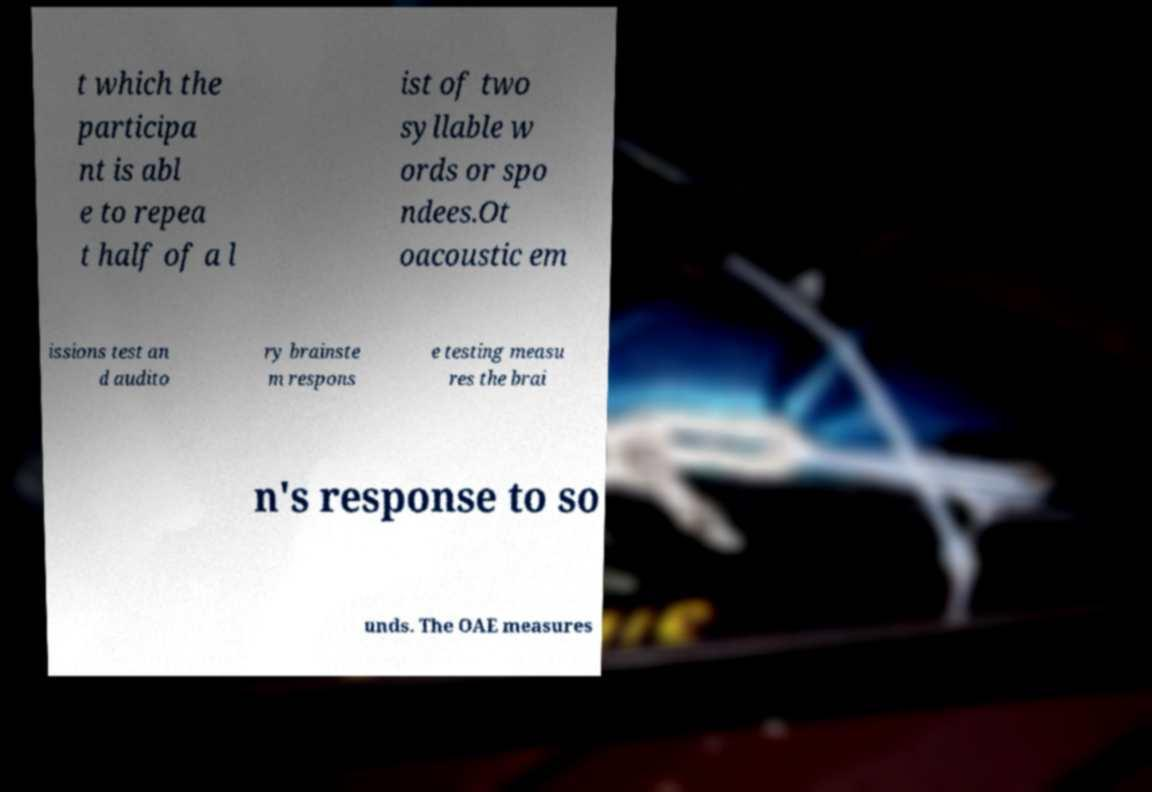Could you assist in decoding the text presented in this image and type it out clearly? t which the participa nt is abl e to repea t half of a l ist of two syllable w ords or spo ndees.Ot oacoustic em issions test an d audito ry brainste m respons e testing measu res the brai n's response to so unds. The OAE measures 